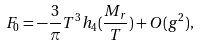<formula> <loc_0><loc_0><loc_500><loc_500>F _ { 0 } = - \frac { 3 } { \pi } T ^ { 3 } h _ { 4 } ( \frac { M _ { r } } { T } ) + O ( g ^ { 2 } ) ,</formula> 